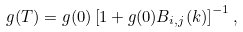Convert formula to latex. <formula><loc_0><loc_0><loc_500><loc_500>g ( T ) = g ( 0 ) \left [ 1 + g ( 0 ) B _ { i , j } ( { k } ) \right ] ^ { - 1 } ,</formula> 